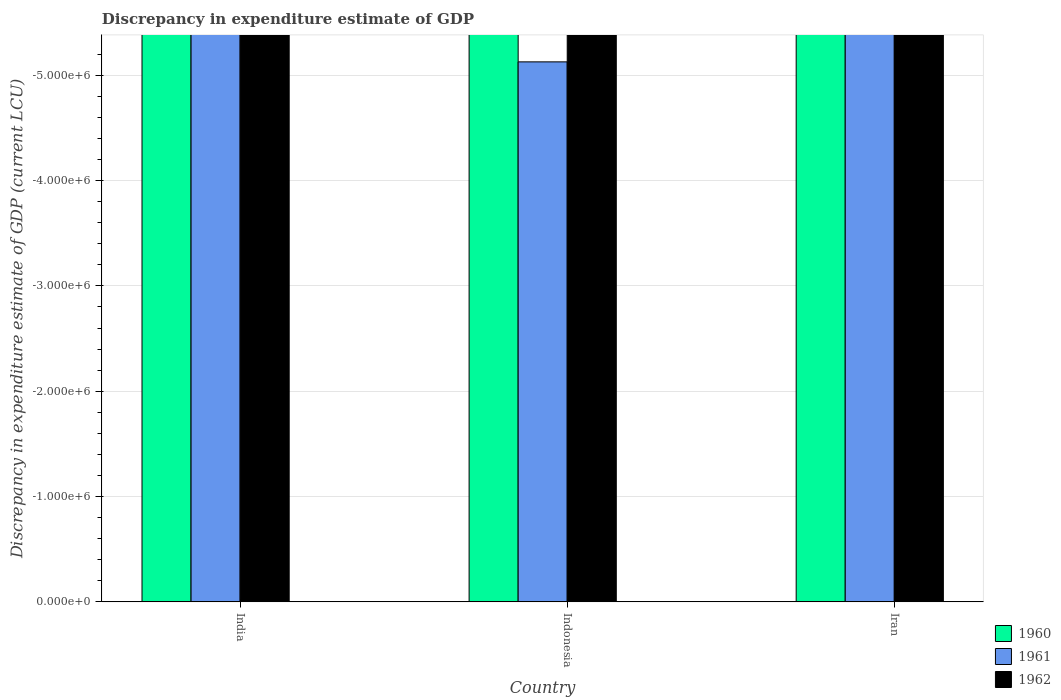How many different coloured bars are there?
Provide a short and direct response. 0. Are the number of bars per tick equal to the number of legend labels?
Make the answer very short. No. How many bars are there on the 2nd tick from the left?
Offer a terse response. 0. What is the label of the 1st group of bars from the left?
Your response must be concise. India. What is the discrepancy in expenditure estimate of GDP in 1962 in India?
Provide a short and direct response. 0. Across all countries, what is the minimum discrepancy in expenditure estimate of GDP in 1960?
Give a very brief answer. 0. What is the total discrepancy in expenditure estimate of GDP in 1961 in the graph?
Your response must be concise. 0. What is the difference between the discrepancy in expenditure estimate of GDP in 1962 in India and the discrepancy in expenditure estimate of GDP in 1961 in Indonesia?
Your answer should be compact. 0. In how many countries, is the discrepancy in expenditure estimate of GDP in 1960 greater than -5000000 LCU?
Your response must be concise. 0. In how many countries, is the discrepancy in expenditure estimate of GDP in 1962 greater than the average discrepancy in expenditure estimate of GDP in 1962 taken over all countries?
Give a very brief answer. 0. How many bars are there?
Offer a very short reply. 0. How many countries are there in the graph?
Your answer should be very brief. 3. Are the values on the major ticks of Y-axis written in scientific E-notation?
Give a very brief answer. Yes. Does the graph contain any zero values?
Your answer should be compact. Yes. Does the graph contain grids?
Your answer should be very brief. Yes. What is the title of the graph?
Provide a succinct answer. Discrepancy in expenditure estimate of GDP. Does "1991" appear as one of the legend labels in the graph?
Keep it short and to the point. No. What is the label or title of the X-axis?
Make the answer very short. Country. What is the label or title of the Y-axis?
Your response must be concise. Discrepancy in expenditure estimate of GDP (current LCU). What is the Discrepancy in expenditure estimate of GDP (current LCU) of 1960 in India?
Make the answer very short. 0. What is the Discrepancy in expenditure estimate of GDP (current LCU) in 1961 in Indonesia?
Provide a short and direct response. 0. What is the Discrepancy in expenditure estimate of GDP (current LCU) of 1962 in Indonesia?
Provide a succinct answer. 0. What is the Discrepancy in expenditure estimate of GDP (current LCU) in 1960 in Iran?
Keep it short and to the point. 0. What is the Discrepancy in expenditure estimate of GDP (current LCU) of 1962 in Iran?
Your answer should be very brief. 0. What is the total Discrepancy in expenditure estimate of GDP (current LCU) of 1962 in the graph?
Keep it short and to the point. 0. What is the average Discrepancy in expenditure estimate of GDP (current LCU) of 1960 per country?
Provide a succinct answer. 0. 